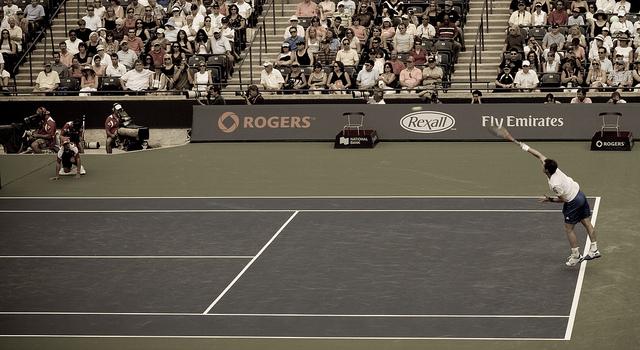Is this picture taken from a good seat?
Short answer required. Yes. According to the sign, what should you 'Fly'?
Give a very brief answer. Emirates. Is the man hitting something?
Give a very brief answer. Yes. What sport is this?
Write a very short answer. Tennis. What color is the ball?
Answer briefly. Yellow. What is on the green turf?
Concise answer only. Tennis player. Which tennis player is serving?
Short answer required. Right. 